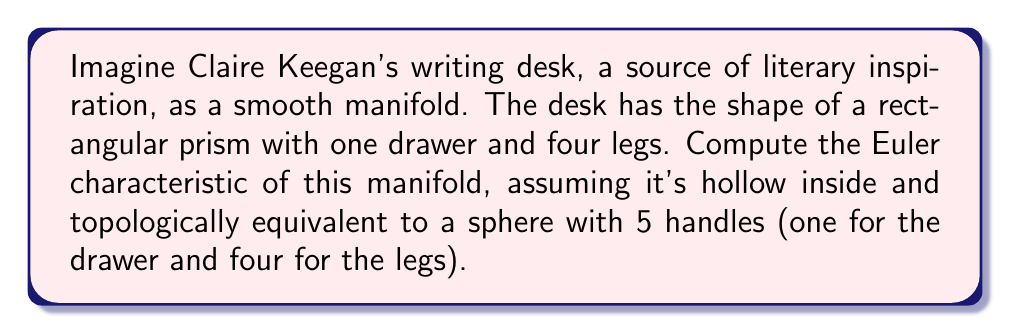Help me with this question. To compute the Euler characteristic of this manifold, we'll follow these steps:

1) Recall the formula for the Euler characteristic of a closed, orientable surface:

   $$\chi = 2 - 2g$$

   where $g$ is the genus (number of handles) of the surface.

2) In this case, our writing desk is topologically equivalent to a sphere with 5 handles (one for the drawer and four for the legs). So, $g = 5$.

3) Substituting into the formula:

   $$\chi = 2 - 2(5)$$
   $$\chi = 2 - 10$$
   $$\chi = -8$$

4) To visualize this, we can think of the desk as follows:
   - Start with a sphere (Euler characteristic 2)
   - Add 5 handles, each decreasing the Euler characteristic by 2

[asy]
import geometry;

size(200);
draw(circle((0,0),1));
for(int i=0; i<5; ++i) {
  pair p = dir(72*i);
  draw(ellipse(p,0.2,0.1));
}
label("Sphere with 5 handles", (0,-1.5));
[/asy]

5) Each handle transforms the surface in a way that's equivalent to removing two disks and attaching a cylinder, which reduces the Euler characteristic by 2.

This result tells us that despite its familiar shape, Claire Keegan's writing desk, when considered as a manifold, has some complex topological properties, much like the depth and complexity found in her literary works.
Answer: $\chi = -8$ 